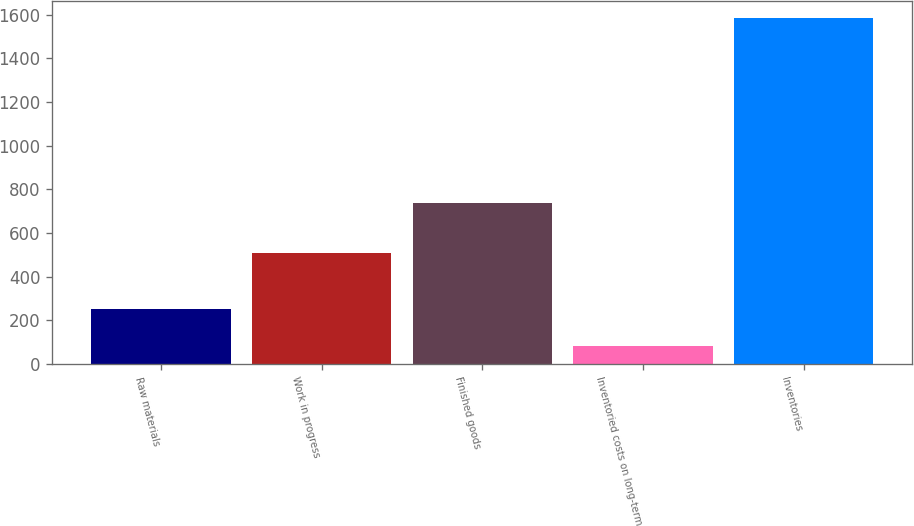<chart> <loc_0><loc_0><loc_500><loc_500><bar_chart><fcel>Raw materials<fcel>Work in progress<fcel>Finished goods<fcel>Inventoried costs on long-term<fcel>Inventories<nl><fcel>253<fcel>509<fcel>739<fcel>82<fcel>1583<nl></chart> 